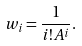<formula> <loc_0><loc_0><loc_500><loc_500>w _ { i } = \frac { 1 } { i ! A ^ { i } } .</formula> 